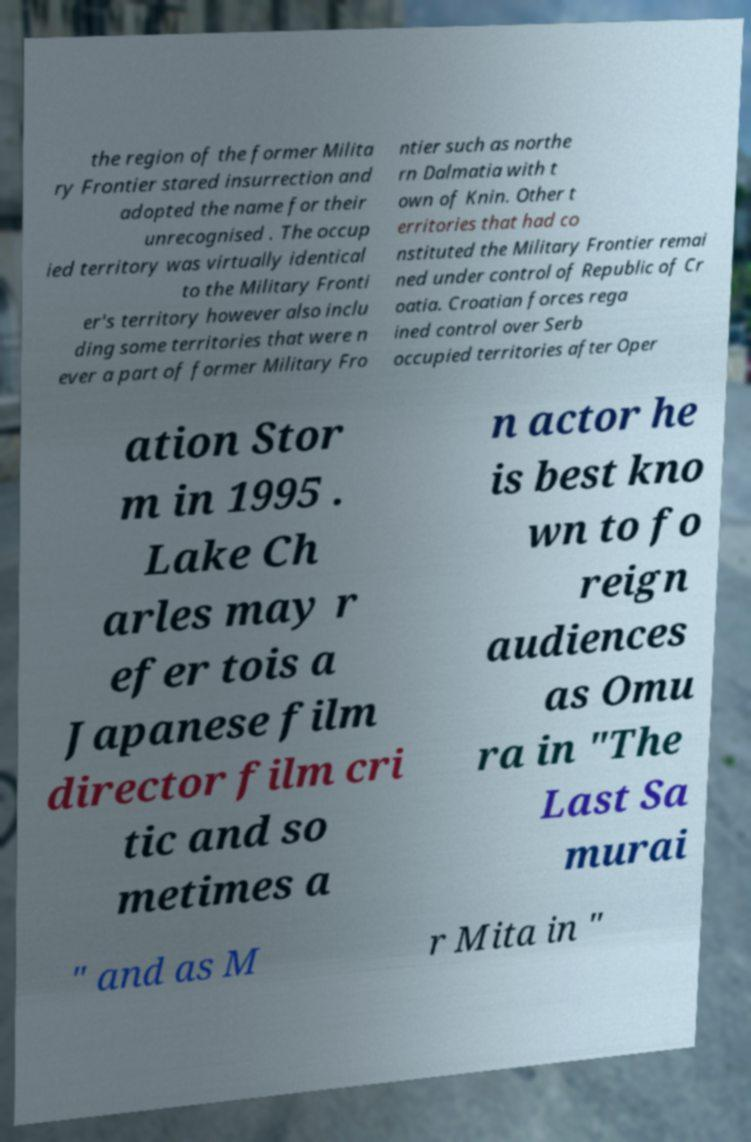Can you read and provide the text displayed in the image?This photo seems to have some interesting text. Can you extract and type it out for me? the region of the former Milita ry Frontier stared insurrection and adopted the name for their unrecognised . The occup ied territory was virtually identical to the Military Fronti er's territory however also inclu ding some territories that were n ever a part of former Military Fro ntier such as northe rn Dalmatia with t own of Knin. Other t erritories that had co nstituted the Military Frontier remai ned under control of Republic of Cr oatia. Croatian forces rega ined control over Serb occupied territories after Oper ation Stor m in 1995 . Lake Ch arles may r efer tois a Japanese film director film cri tic and so metimes a n actor he is best kno wn to fo reign audiences as Omu ra in "The Last Sa murai " and as M r Mita in " 